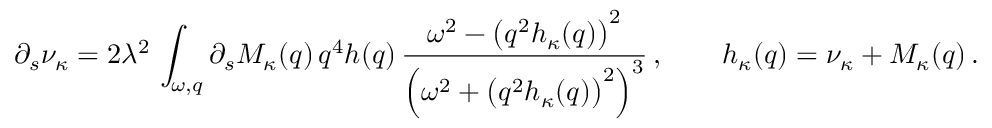<formula> <loc_0><loc_0><loc_500><loc_500>\partial _ { s } \nu _ { \kappa } = 2 \lambda ^ { 2 } \, \int _ { \omega , q } \partial _ { s } M _ { \kappa } ( q ) \, q ^ { 4 } h ( q ) \, \frac { \omega ^ { 2 } - \left ( q ^ { 2 } h _ { \kappa } ( q ) \right ) ^ { 2 } } { \left ( \omega ^ { 2 } + \left ( q ^ { 2 } h _ { \kappa } ( q ) \right ) ^ { 2 } \right ) ^ { 3 } } \, , \quad h _ { \kappa } ( q ) = \nu _ { \kappa } + M _ { \kappa } ( q ) \, .</formula> 